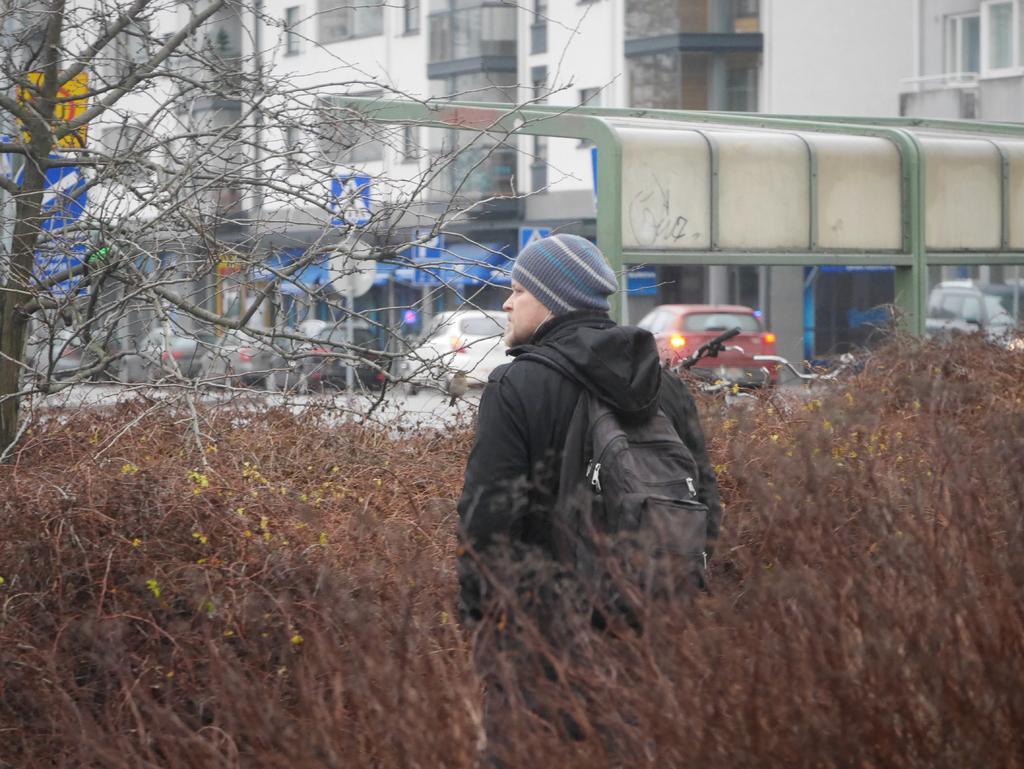In one or two sentences, can you explain what this image depicts? In the middle of the image we can see a man, he is carrying a backpack, beside him we can find a tree and few plants, in the background we can see few vehicles, sign boards and buildings. 